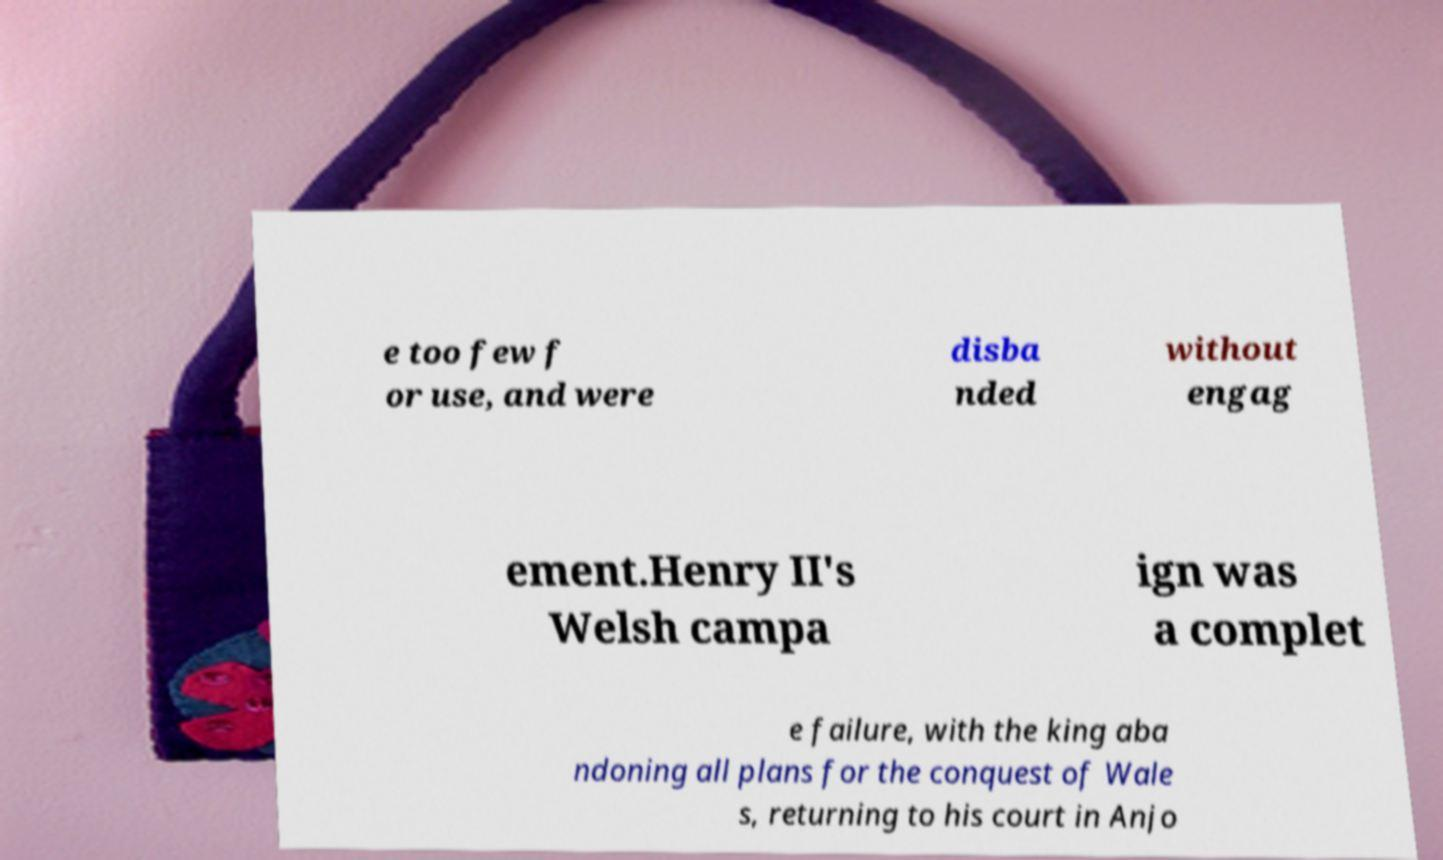There's text embedded in this image that I need extracted. Can you transcribe it verbatim? e too few f or use, and were disba nded without engag ement.Henry II's Welsh campa ign was a complet e failure, with the king aba ndoning all plans for the conquest of Wale s, returning to his court in Anjo 